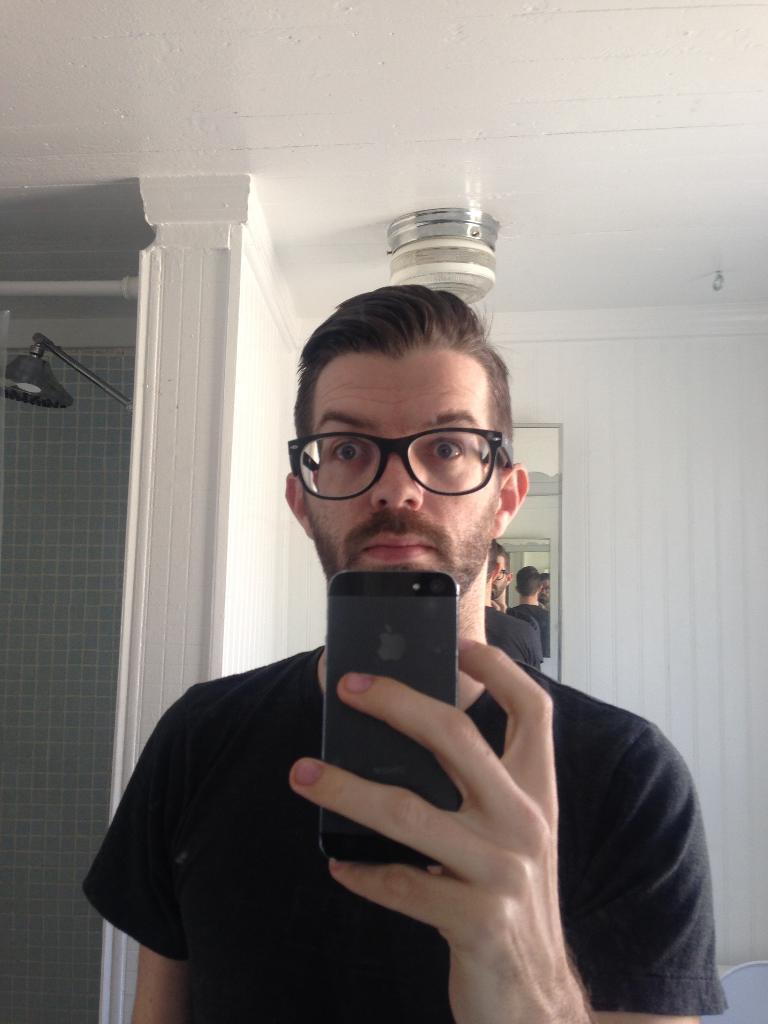Describe this image in one or two sentences. In this image i can see a man standing and holding a mobile, at the back ground i can see a shower, a mirror attached to a wall. 